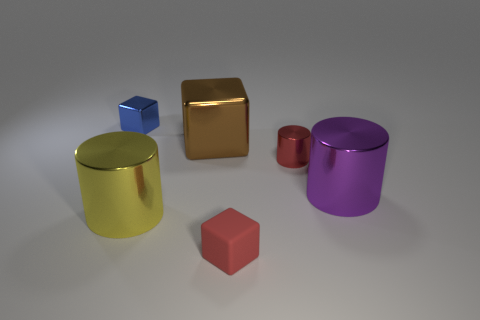Add 3 small cylinders. How many objects exist? 9 Subtract 1 cylinders. How many cylinders are left? 2 Subtract all small blocks. How many blocks are left? 1 Subtract 1 purple cylinders. How many objects are left? 5 Subtract all tiny yellow matte cylinders. Subtract all yellow objects. How many objects are left? 5 Add 2 small blue things. How many small blue things are left? 3 Add 5 red blocks. How many red blocks exist? 6 